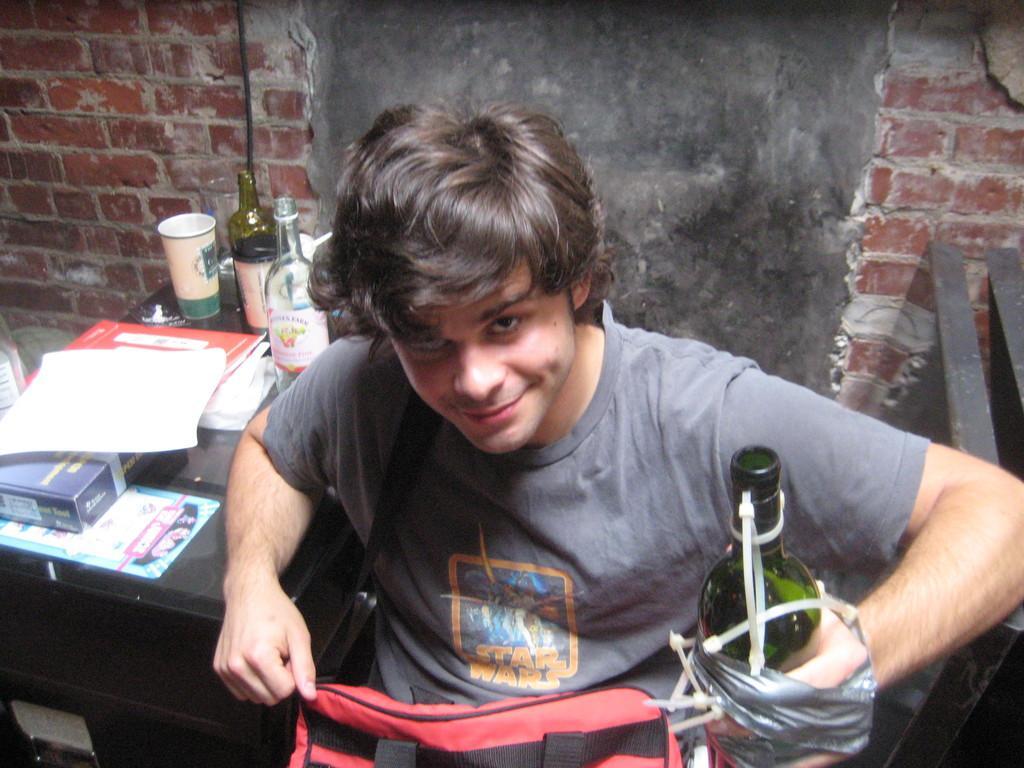Please provide a concise description of this image. This is the picture of inside of the room. There is a person holding the bottle with his left hand and at the left side of the image there is a paper, book, bottle, cup on the table. 